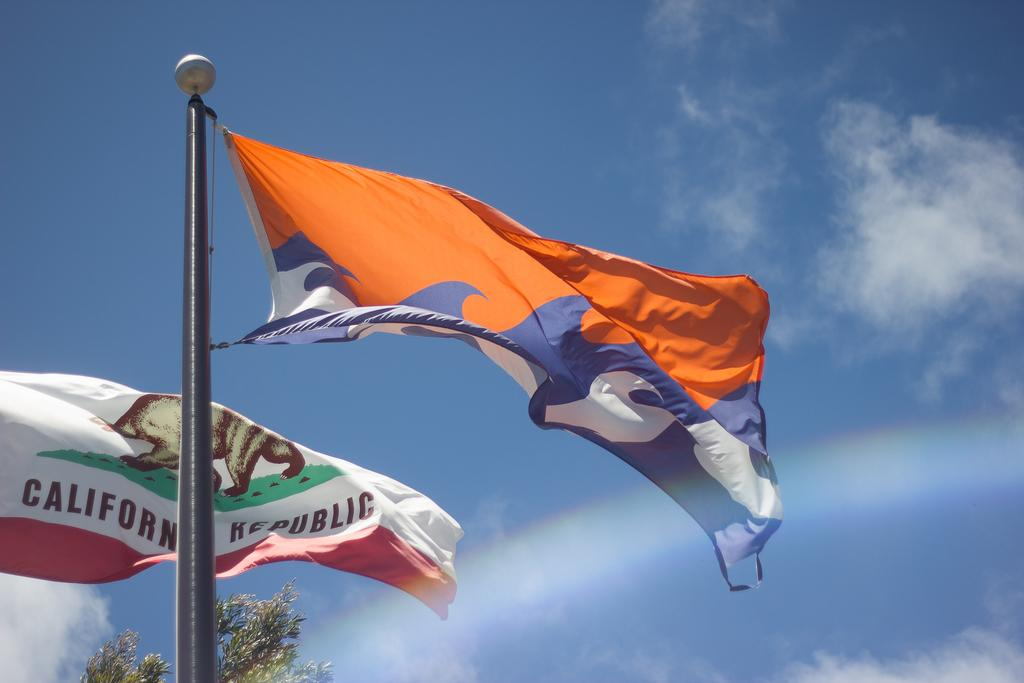What is attached to the pole in the image? There is a flag attached to a pole in the image. Are there any other flags visible in the image? Yes, there is another flag in the left corner of the image. What color is the sky in the image? The sky is blue in the image. What type of beef is being prepared in the image? There is no beef present in the image; it features flags and a blue sky. How many giants can be seen in the image? There are no giants present in the image. 